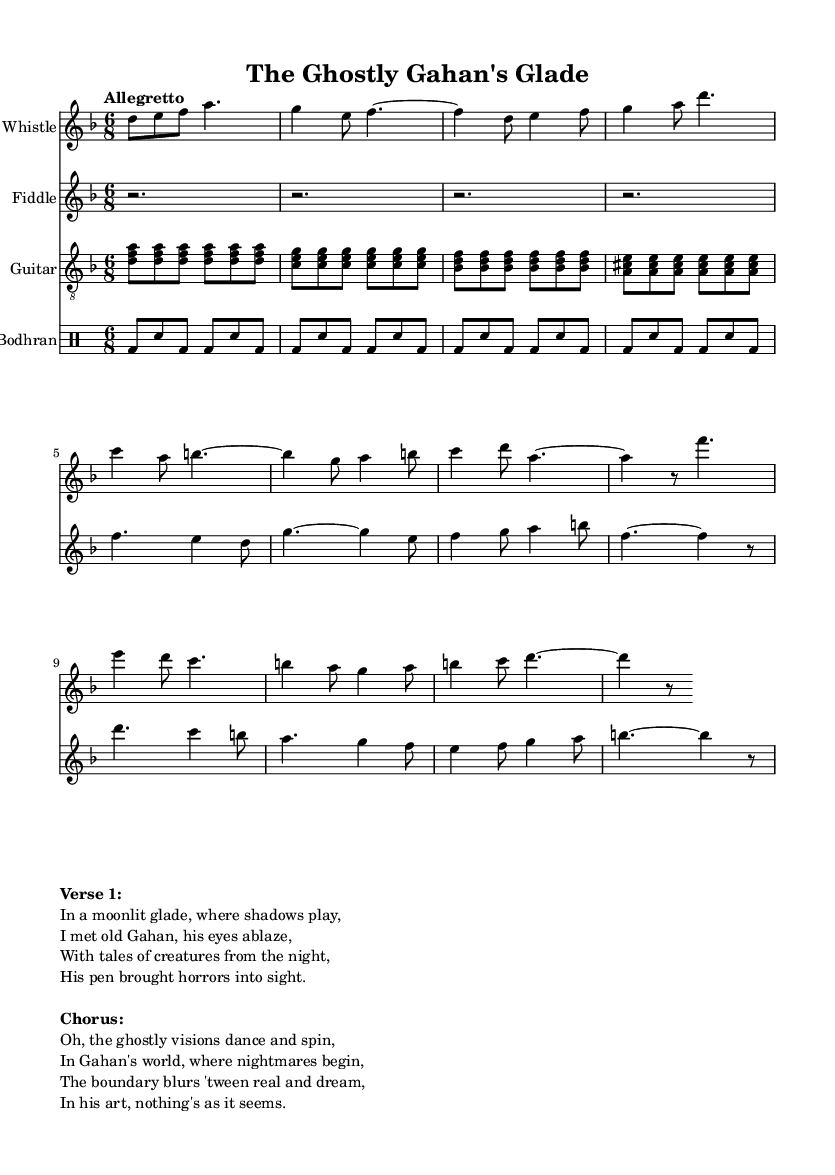What is the key signature of this music? The key signature shown at the beginning of the score indicates D minor, which has one flat (B flat).
Answer: D minor What is the time signature of this piece? The time signature is displayed at the beginning of the music sheet as 6/8, indicating a compound duple meter with six eighth notes per measure.
Answer: 6/8 What is the tempo marking of this composition? The tempo marking provided indicates "Allegretto," suggesting a moderately fast pace but not as fast as "Allegro."
Answer: Allegretto What instrument plays the main melody? The tin whistle is indicated as the primary instrument playing the melody throughout the piece.
Answer: Tin Whistle How many measures are in the intro section? The intro section consists of four measures, which can be counted from the provided music notation at the beginning.
Answer: 4 What is the theme of the lyrics in the verse? The lyrics in the verse revolve around encounters with supernatural beings and the eerie stories told by Gahan Wilson.
Answer: Supernatural encounters Which instruments are featured in this score? The score lists four instruments: Tin Whistle, Fiddle, Guitar, and Bodhran, which are clearly indicated at the beginning of each staff.
Answer: Tin Whistle, Fiddle, Guitar, Bodhran 